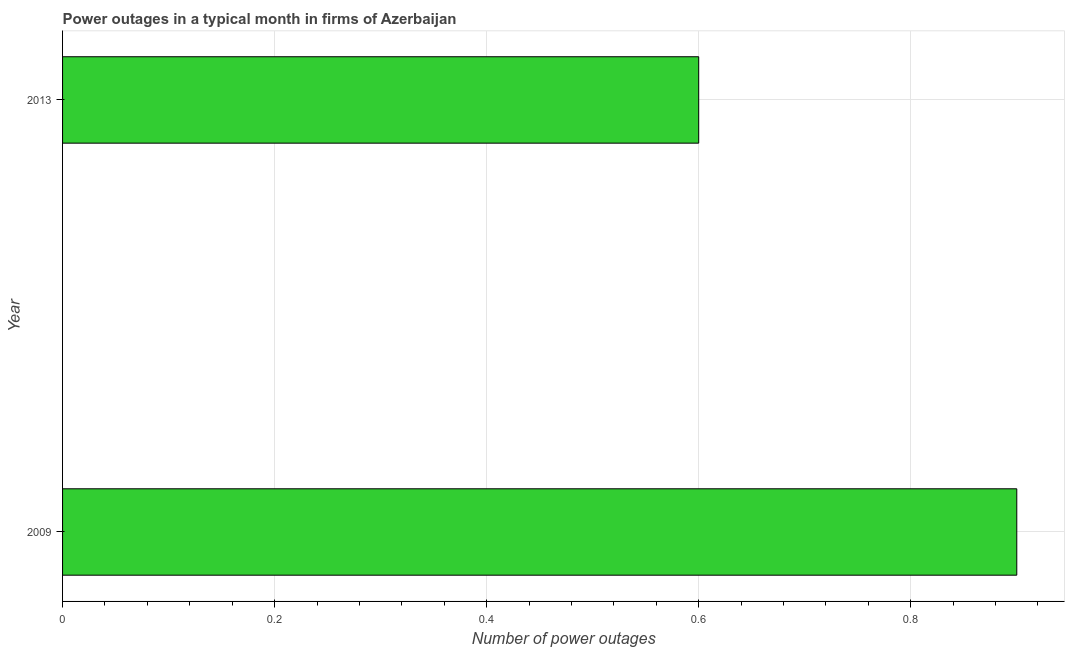What is the title of the graph?
Offer a very short reply. Power outages in a typical month in firms of Azerbaijan. What is the label or title of the X-axis?
Provide a succinct answer. Number of power outages. What is the label or title of the Y-axis?
Your answer should be very brief. Year. What is the number of power outages in 2009?
Make the answer very short. 0.9. Across all years, what is the minimum number of power outages?
Ensure brevity in your answer.  0.6. In which year was the number of power outages minimum?
Make the answer very short. 2013. What is the difference between the number of power outages in 2009 and 2013?
Make the answer very short. 0.3. Do a majority of the years between 2009 and 2013 (inclusive) have number of power outages greater than 0.08 ?
Offer a terse response. Yes. What is the ratio of the number of power outages in 2009 to that in 2013?
Give a very brief answer. 1.5. Is the number of power outages in 2009 less than that in 2013?
Make the answer very short. No. How many bars are there?
Offer a very short reply. 2. What is the difference between two consecutive major ticks on the X-axis?
Make the answer very short. 0.2. Are the values on the major ticks of X-axis written in scientific E-notation?
Keep it short and to the point. No. What is the Number of power outages in 2009?
Ensure brevity in your answer.  0.9. What is the difference between the Number of power outages in 2009 and 2013?
Your response must be concise. 0.3. 